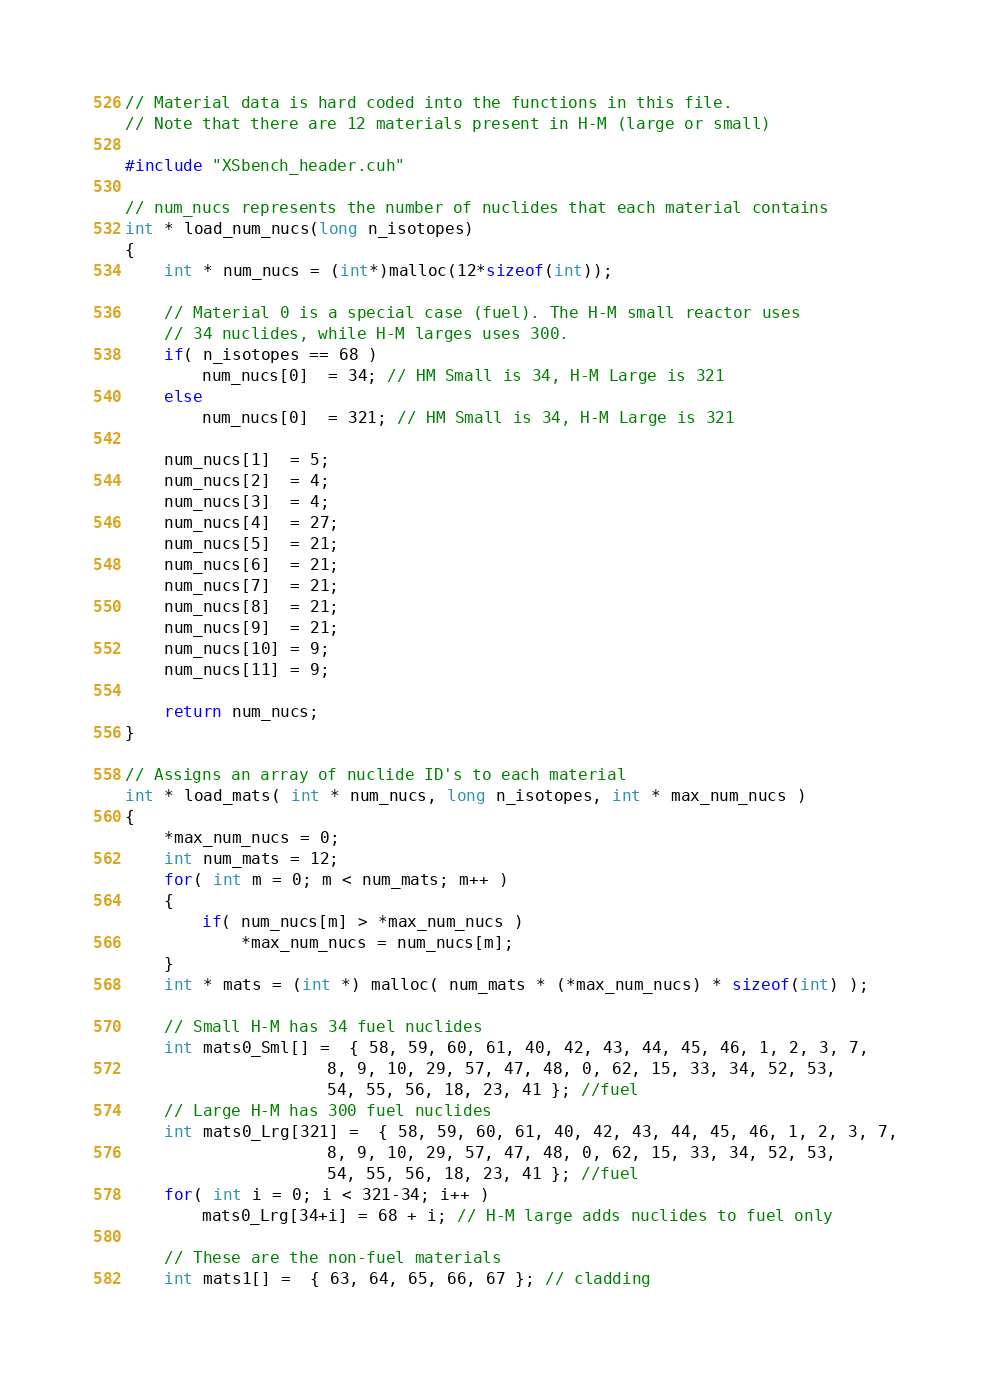<code> <loc_0><loc_0><loc_500><loc_500><_Cuda_>// Material data is hard coded into the functions in this file.
// Note that there are 12 materials present in H-M (large or small)

#include "XSbench_header.cuh"

// num_nucs represents the number of nuclides that each material contains
int * load_num_nucs(long n_isotopes)
{
	int * num_nucs = (int*)malloc(12*sizeof(int));
	
	// Material 0 is a special case (fuel). The H-M small reactor uses
	// 34 nuclides, while H-M larges uses 300.
	if( n_isotopes == 68 )
		num_nucs[0]  = 34; // HM Small is 34, H-M Large is 321
	else
		num_nucs[0]  = 321; // HM Small is 34, H-M Large is 321

	num_nucs[1]  = 5;
	num_nucs[2]  = 4;
	num_nucs[3]  = 4;
	num_nucs[4]  = 27;
	num_nucs[5]  = 21;
	num_nucs[6]  = 21;
	num_nucs[7]  = 21;
	num_nucs[8]  = 21;
	num_nucs[9]  = 21;
	num_nucs[10] = 9;
	num_nucs[11] = 9;

	return num_nucs;
}

// Assigns an array of nuclide ID's to each material
int * load_mats( int * num_nucs, long n_isotopes, int * max_num_nucs )
{
	*max_num_nucs = 0;
	int num_mats = 12;
	for( int m = 0; m < num_mats; m++ )
	{
		if( num_nucs[m] > *max_num_nucs )
			*max_num_nucs = num_nucs[m];
	}
	int * mats = (int *) malloc( num_mats * (*max_num_nucs) * sizeof(int) );

	// Small H-M has 34 fuel nuclides
	int mats0_Sml[] =  { 58, 59, 60, 61, 40, 42, 43, 44, 45, 46, 1, 2, 3, 7,
	                 8, 9, 10, 29, 57, 47, 48, 0, 62, 15, 33, 34, 52, 53, 
	                 54, 55, 56, 18, 23, 41 }; //fuel
	// Large H-M has 300 fuel nuclides
	int mats0_Lrg[321] =  { 58, 59, 60, 61, 40, 42, 43, 44, 45, 46, 1, 2, 3, 7,
	                 8, 9, 10, 29, 57, 47, 48, 0, 62, 15, 33, 34, 52, 53,
	                 54, 55, 56, 18, 23, 41 }; //fuel
	for( int i = 0; i < 321-34; i++ )
		mats0_Lrg[34+i] = 68 + i; // H-M large adds nuclides to fuel only
	
	// These are the non-fuel materials	
	int mats1[] =  { 63, 64, 65, 66, 67 }; // cladding</code> 